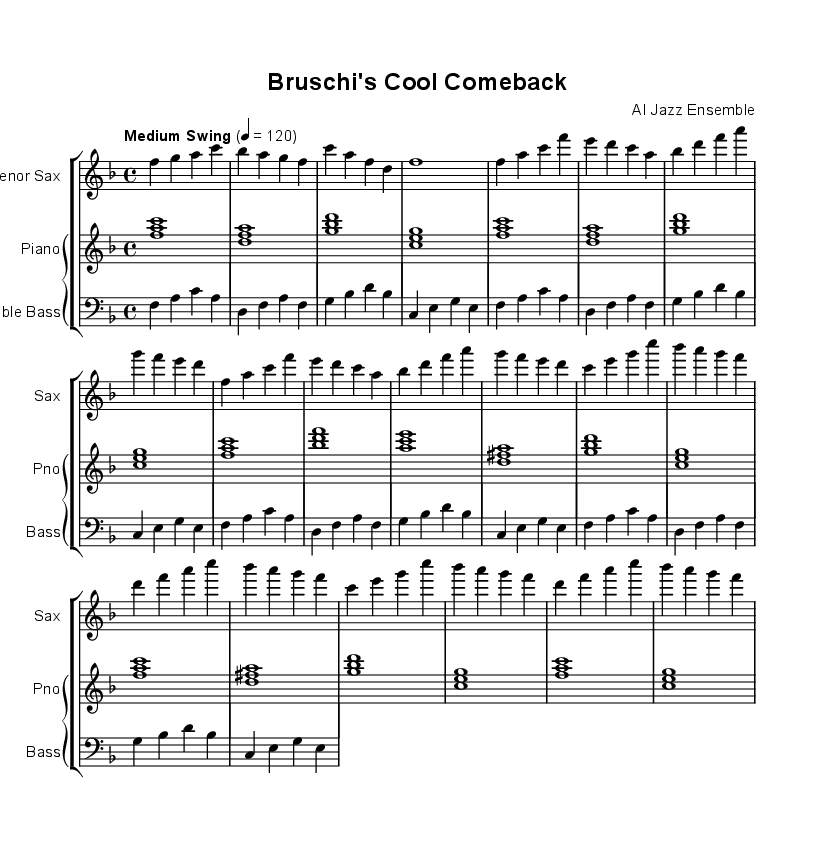What is the key signature of this music? The key signature indicated at the beginning of the sheet music is F major, which has one flat (B flat). This can be deduced from the key signature notated on the first staff.
Answer: F major What is the time signature of the music? The time signature present in the sheet music is 4/4, shown at the start of the score. This indicates that each measure has four beats, and the quarter note gets one beat.
Answer: 4/4 What is the tempo marking for this piece? The tempo marking "Medium Swing" followed by a metronome marking of 120 is found at the beginning of the score. This indicates the speed and style in which the piece should be played.
Answer: Medium Swing, 120 How many measures are in the A section? The A section of the music consists of eight measures, which can be observed by counting the measures indicated in the repeated section of the score.
Answer: 8 measures What instruments are featured in this arrangement? The sheet music features a tenor saxophone, piano, and double bass as indicated on the respective staff names at the beginning of each part.
Answer: Tenor Sax, Piano, Double Bass Which sections of the music are repeated? The A section is repeated after the first play, as indicated by the repeat signs. The presence of identical measures in the same section confirms it is repeated.
Answer: A section What is the pattern of the bass line in the music? The bass line pattern follows a repetitive structure of four measures, focusing on the fundamental notes F, A, C, and ascending through the scale, which can be seen from the notated notes in the bass staff.
Answer: Repetitive structure 